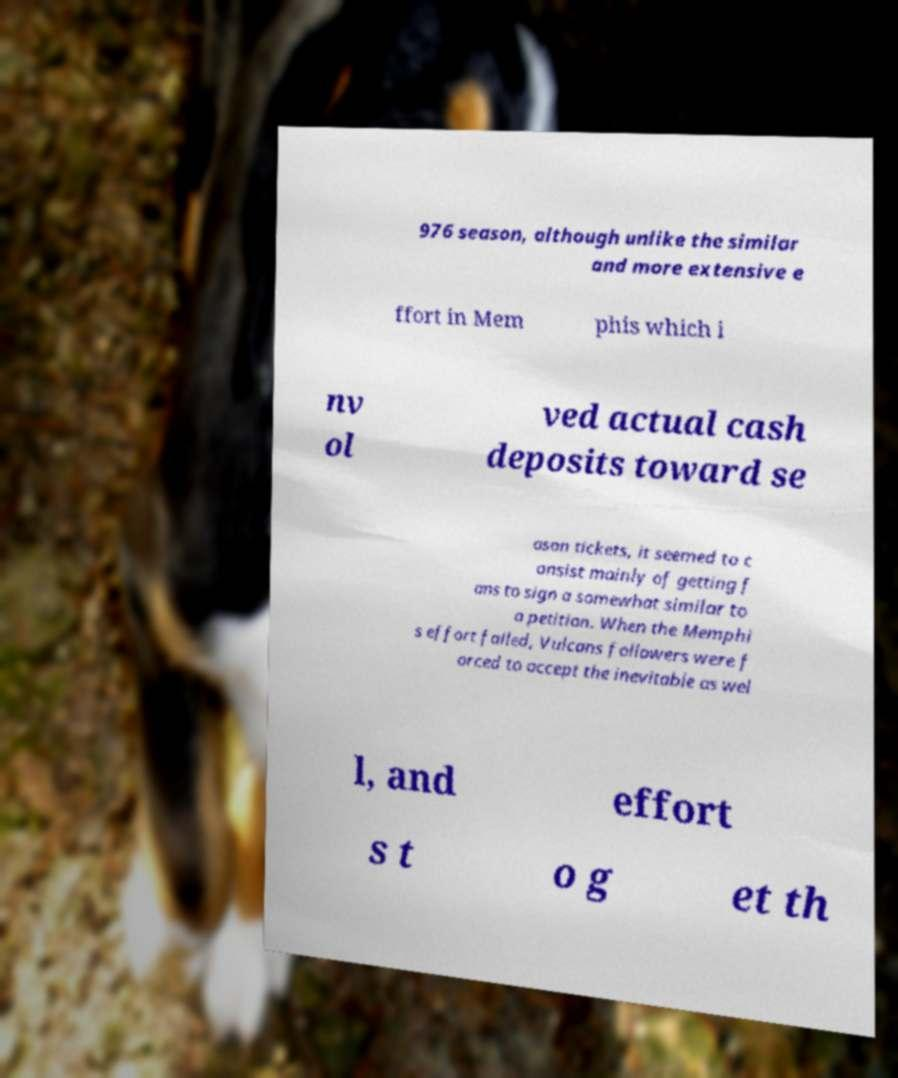Can you accurately transcribe the text from the provided image for me? 976 season, although unlike the similar and more extensive e ffort in Mem phis which i nv ol ved actual cash deposits toward se ason tickets, it seemed to c onsist mainly of getting f ans to sign a somewhat similar to a petition. When the Memphi s effort failed, Vulcans followers were f orced to accept the inevitable as wel l, and effort s t o g et th 